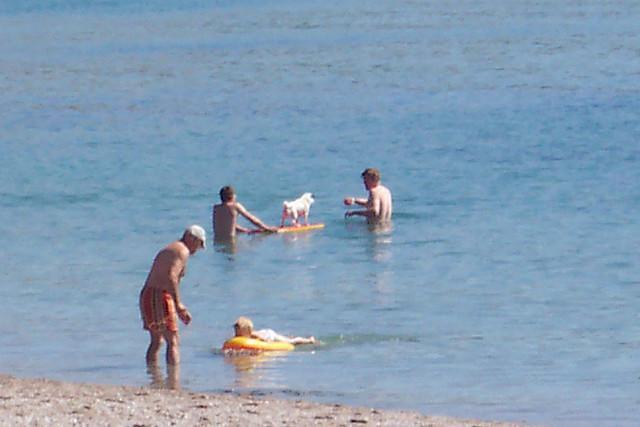How many people are in the water?
Give a very brief answer. 4. How many people are in the photo?
Give a very brief answer. 4. How many horses have white on them?
Give a very brief answer. 0. 